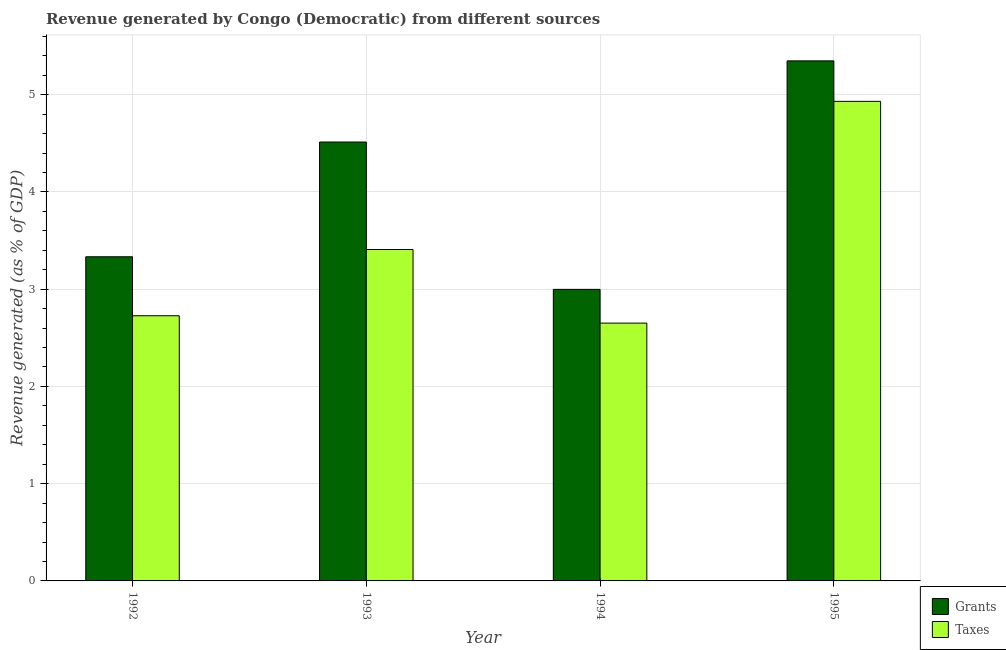How many groups of bars are there?
Your response must be concise. 4. Are the number of bars per tick equal to the number of legend labels?
Offer a very short reply. Yes. Are the number of bars on each tick of the X-axis equal?
Provide a short and direct response. Yes. In how many cases, is the number of bars for a given year not equal to the number of legend labels?
Provide a short and direct response. 0. What is the revenue generated by grants in 1992?
Offer a very short reply. 3.33. Across all years, what is the maximum revenue generated by grants?
Provide a succinct answer. 5.35. Across all years, what is the minimum revenue generated by grants?
Your response must be concise. 3. In which year was the revenue generated by taxes maximum?
Provide a short and direct response. 1995. In which year was the revenue generated by grants minimum?
Your answer should be very brief. 1994. What is the total revenue generated by taxes in the graph?
Make the answer very short. 13.72. What is the difference between the revenue generated by grants in 1992 and that in 1995?
Give a very brief answer. -2.01. What is the difference between the revenue generated by grants in 1993 and the revenue generated by taxes in 1995?
Offer a terse response. -0.83. What is the average revenue generated by grants per year?
Your response must be concise. 4.05. In the year 1993, what is the difference between the revenue generated by taxes and revenue generated by grants?
Provide a short and direct response. 0. In how many years, is the revenue generated by grants greater than 4.2 %?
Offer a terse response. 2. What is the ratio of the revenue generated by grants in 1994 to that in 1995?
Your answer should be compact. 0.56. Is the difference between the revenue generated by grants in 1993 and 1994 greater than the difference between the revenue generated by taxes in 1993 and 1994?
Your answer should be compact. No. What is the difference between the highest and the second highest revenue generated by taxes?
Offer a terse response. 1.52. What is the difference between the highest and the lowest revenue generated by grants?
Make the answer very short. 2.35. What does the 1st bar from the left in 1994 represents?
Your answer should be compact. Grants. What does the 1st bar from the right in 1992 represents?
Give a very brief answer. Taxes. How many bars are there?
Your answer should be very brief. 8. Are the values on the major ticks of Y-axis written in scientific E-notation?
Keep it short and to the point. No. Does the graph contain any zero values?
Provide a short and direct response. No. Does the graph contain grids?
Provide a succinct answer. Yes. What is the title of the graph?
Your answer should be very brief. Revenue generated by Congo (Democratic) from different sources. What is the label or title of the X-axis?
Make the answer very short. Year. What is the label or title of the Y-axis?
Your answer should be very brief. Revenue generated (as % of GDP). What is the Revenue generated (as % of GDP) in Grants in 1992?
Ensure brevity in your answer.  3.33. What is the Revenue generated (as % of GDP) of Taxes in 1992?
Provide a short and direct response. 2.73. What is the Revenue generated (as % of GDP) of Grants in 1993?
Offer a terse response. 4.51. What is the Revenue generated (as % of GDP) of Taxes in 1993?
Offer a very short reply. 3.41. What is the Revenue generated (as % of GDP) in Grants in 1994?
Make the answer very short. 3. What is the Revenue generated (as % of GDP) of Taxes in 1994?
Offer a terse response. 2.65. What is the Revenue generated (as % of GDP) of Grants in 1995?
Offer a terse response. 5.35. What is the Revenue generated (as % of GDP) in Taxes in 1995?
Offer a terse response. 4.93. Across all years, what is the maximum Revenue generated (as % of GDP) in Grants?
Ensure brevity in your answer.  5.35. Across all years, what is the maximum Revenue generated (as % of GDP) of Taxes?
Your answer should be very brief. 4.93. Across all years, what is the minimum Revenue generated (as % of GDP) of Grants?
Provide a succinct answer. 3. Across all years, what is the minimum Revenue generated (as % of GDP) in Taxes?
Your response must be concise. 2.65. What is the total Revenue generated (as % of GDP) of Grants in the graph?
Keep it short and to the point. 16.19. What is the total Revenue generated (as % of GDP) of Taxes in the graph?
Your answer should be compact. 13.72. What is the difference between the Revenue generated (as % of GDP) in Grants in 1992 and that in 1993?
Provide a short and direct response. -1.18. What is the difference between the Revenue generated (as % of GDP) of Taxes in 1992 and that in 1993?
Give a very brief answer. -0.68. What is the difference between the Revenue generated (as % of GDP) in Grants in 1992 and that in 1994?
Provide a short and direct response. 0.34. What is the difference between the Revenue generated (as % of GDP) in Taxes in 1992 and that in 1994?
Give a very brief answer. 0.08. What is the difference between the Revenue generated (as % of GDP) of Grants in 1992 and that in 1995?
Offer a very short reply. -2.01. What is the difference between the Revenue generated (as % of GDP) in Taxes in 1992 and that in 1995?
Provide a succinct answer. -2.2. What is the difference between the Revenue generated (as % of GDP) of Grants in 1993 and that in 1994?
Provide a short and direct response. 1.52. What is the difference between the Revenue generated (as % of GDP) in Taxes in 1993 and that in 1994?
Keep it short and to the point. 0.76. What is the difference between the Revenue generated (as % of GDP) of Grants in 1993 and that in 1995?
Give a very brief answer. -0.83. What is the difference between the Revenue generated (as % of GDP) in Taxes in 1993 and that in 1995?
Provide a short and direct response. -1.52. What is the difference between the Revenue generated (as % of GDP) in Grants in 1994 and that in 1995?
Give a very brief answer. -2.35. What is the difference between the Revenue generated (as % of GDP) of Taxes in 1994 and that in 1995?
Ensure brevity in your answer.  -2.28. What is the difference between the Revenue generated (as % of GDP) in Grants in 1992 and the Revenue generated (as % of GDP) in Taxes in 1993?
Keep it short and to the point. -0.07. What is the difference between the Revenue generated (as % of GDP) of Grants in 1992 and the Revenue generated (as % of GDP) of Taxes in 1994?
Give a very brief answer. 0.68. What is the difference between the Revenue generated (as % of GDP) in Grants in 1992 and the Revenue generated (as % of GDP) in Taxes in 1995?
Provide a succinct answer. -1.6. What is the difference between the Revenue generated (as % of GDP) of Grants in 1993 and the Revenue generated (as % of GDP) of Taxes in 1994?
Offer a terse response. 1.86. What is the difference between the Revenue generated (as % of GDP) of Grants in 1993 and the Revenue generated (as % of GDP) of Taxes in 1995?
Ensure brevity in your answer.  -0.42. What is the difference between the Revenue generated (as % of GDP) of Grants in 1994 and the Revenue generated (as % of GDP) of Taxes in 1995?
Provide a succinct answer. -1.93. What is the average Revenue generated (as % of GDP) of Grants per year?
Your answer should be very brief. 4.05. What is the average Revenue generated (as % of GDP) in Taxes per year?
Ensure brevity in your answer.  3.43. In the year 1992, what is the difference between the Revenue generated (as % of GDP) of Grants and Revenue generated (as % of GDP) of Taxes?
Provide a short and direct response. 0.61. In the year 1993, what is the difference between the Revenue generated (as % of GDP) in Grants and Revenue generated (as % of GDP) in Taxes?
Provide a short and direct response. 1.11. In the year 1994, what is the difference between the Revenue generated (as % of GDP) in Grants and Revenue generated (as % of GDP) in Taxes?
Provide a succinct answer. 0.35. In the year 1995, what is the difference between the Revenue generated (as % of GDP) in Grants and Revenue generated (as % of GDP) in Taxes?
Provide a succinct answer. 0.42. What is the ratio of the Revenue generated (as % of GDP) in Grants in 1992 to that in 1993?
Offer a terse response. 0.74. What is the ratio of the Revenue generated (as % of GDP) of Taxes in 1992 to that in 1993?
Give a very brief answer. 0.8. What is the ratio of the Revenue generated (as % of GDP) of Grants in 1992 to that in 1994?
Offer a very short reply. 1.11. What is the ratio of the Revenue generated (as % of GDP) in Taxes in 1992 to that in 1994?
Offer a very short reply. 1.03. What is the ratio of the Revenue generated (as % of GDP) of Grants in 1992 to that in 1995?
Make the answer very short. 0.62. What is the ratio of the Revenue generated (as % of GDP) in Taxes in 1992 to that in 1995?
Offer a very short reply. 0.55. What is the ratio of the Revenue generated (as % of GDP) in Grants in 1993 to that in 1994?
Offer a terse response. 1.51. What is the ratio of the Revenue generated (as % of GDP) of Taxes in 1993 to that in 1994?
Give a very brief answer. 1.29. What is the ratio of the Revenue generated (as % of GDP) of Grants in 1993 to that in 1995?
Offer a terse response. 0.84. What is the ratio of the Revenue generated (as % of GDP) of Taxes in 1993 to that in 1995?
Give a very brief answer. 0.69. What is the ratio of the Revenue generated (as % of GDP) in Grants in 1994 to that in 1995?
Offer a very short reply. 0.56. What is the ratio of the Revenue generated (as % of GDP) in Taxes in 1994 to that in 1995?
Provide a short and direct response. 0.54. What is the difference between the highest and the second highest Revenue generated (as % of GDP) in Grants?
Keep it short and to the point. 0.83. What is the difference between the highest and the second highest Revenue generated (as % of GDP) in Taxes?
Provide a succinct answer. 1.52. What is the difference between the highest and the lowest Revenue generated (as % of GDP) of Grants?
Keep it short and to the point. 2.35. What is the difference between the highest and the lowest Revenue generated (as % of GDP) in Taxes?
Make the answer very short. 2.28. 